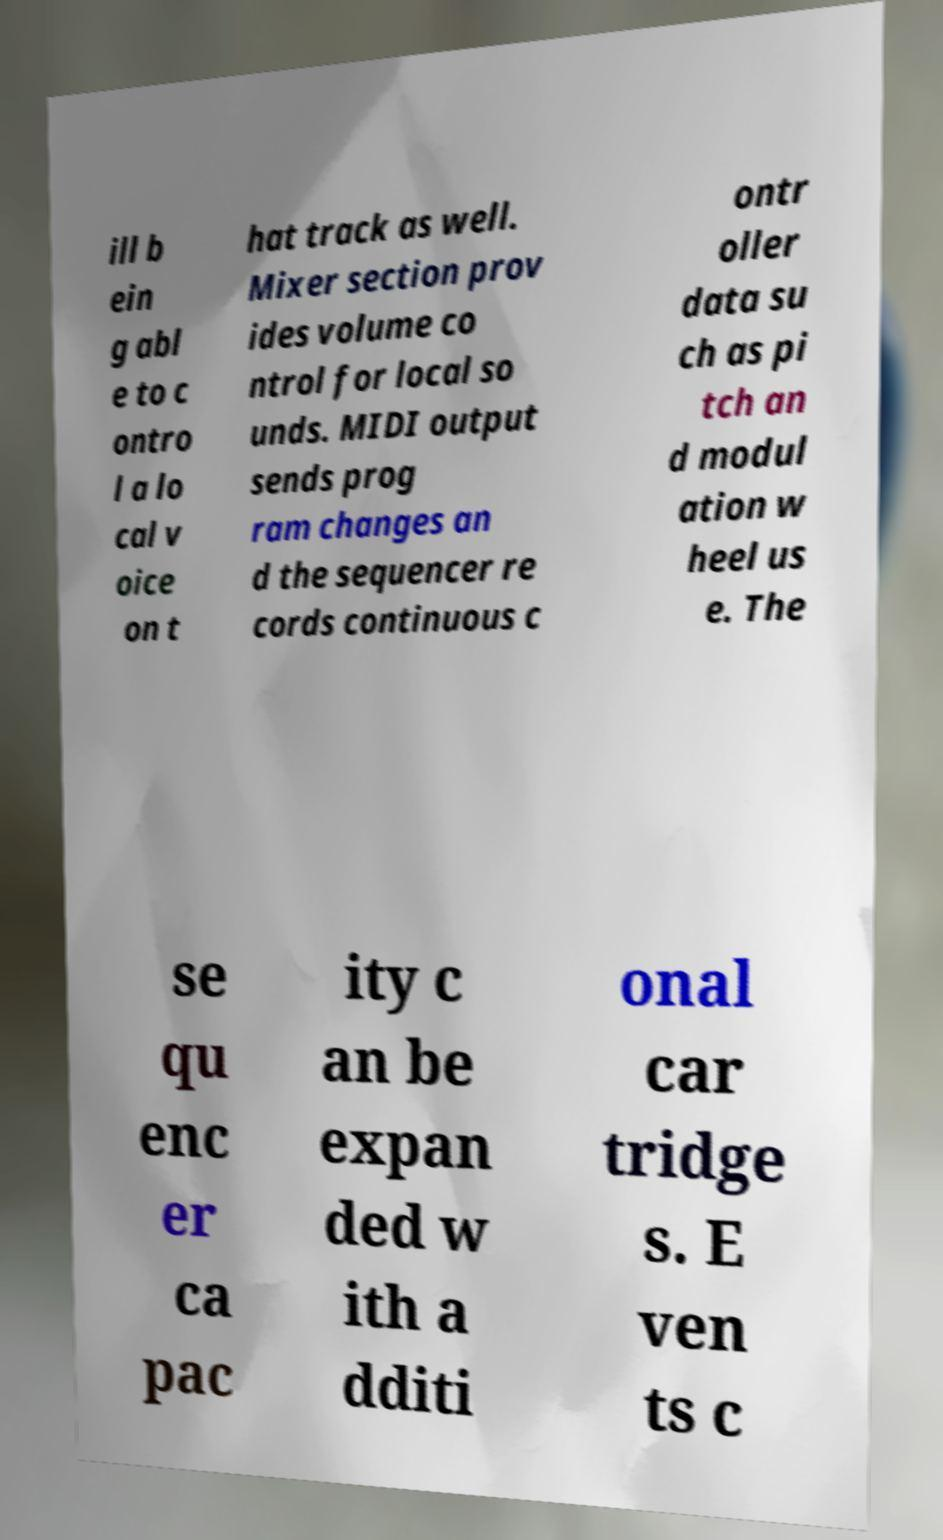What messages or text are displayed in this image? I need them in a readable, typed format. ill b ein g abl e to c ontro l a lo cal v oice on t hat track as well. Mixer section prov ides volume co ntrol for local so unds. MIDI output sends prog ram changes an d the sequencer re cords continuous c ontr oller data su ch as pi tch an d modul ation w heel us e. The se qu enc er ca pac ity c an be expan ded w ith a dditi onal car tridge s. E ven ts c 